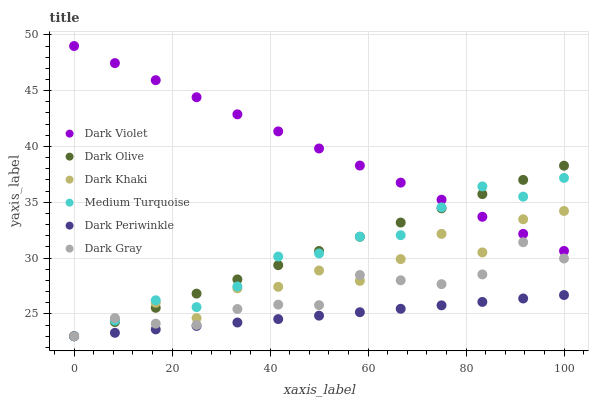Does Dark Periwinkle have the minimum area under the curve?
Answer yes or no. Yes. Does Dark Violet have the maximum area under the curve?
Answer yes or no. Yes. Does Dark Olive have the minimum area under the curve?
Answer yes or no. No. Does Dark Olive have the maximum area under the curve?
Answer yes or no. No. Is Dark Periwinkle the smoothest?
Answer yes or no. Yes. Is Dark Khaki the roughest?
Answer yes or no. Yes. Is Dark Olive the smoothest?
Answer yes or no. No. Is Dark Olive the roughest?
Answer yes or no. No. Does Dark Gray have the lowest value?
Answer yes or no. Yes. Does Dark Violet have the lowest value?
Answer yes or no. No. Does Dark Violet have the highest value?
Answer yes or no. Yes. Does Dark Olive have the highest value?
Answer yes or no. No. Is Dark Periwinkle less than Dark Violet?
Answer yes or no. Yes. Is Dark Violet greater than Dark Gray?
Answer yes or no. Yes. Does Dark Khaki intersect Medium Turquoise?
Answer yes or no. Yes. Is Dark Khaki less than Medium Turquoise?
Answer yes or no. No. Is Dark Khaki greater than Medium Turquoise?
Answer yes or no. No. Does Dark Periwinkle intersect Dark Violet?
Answer yes or no. No. 